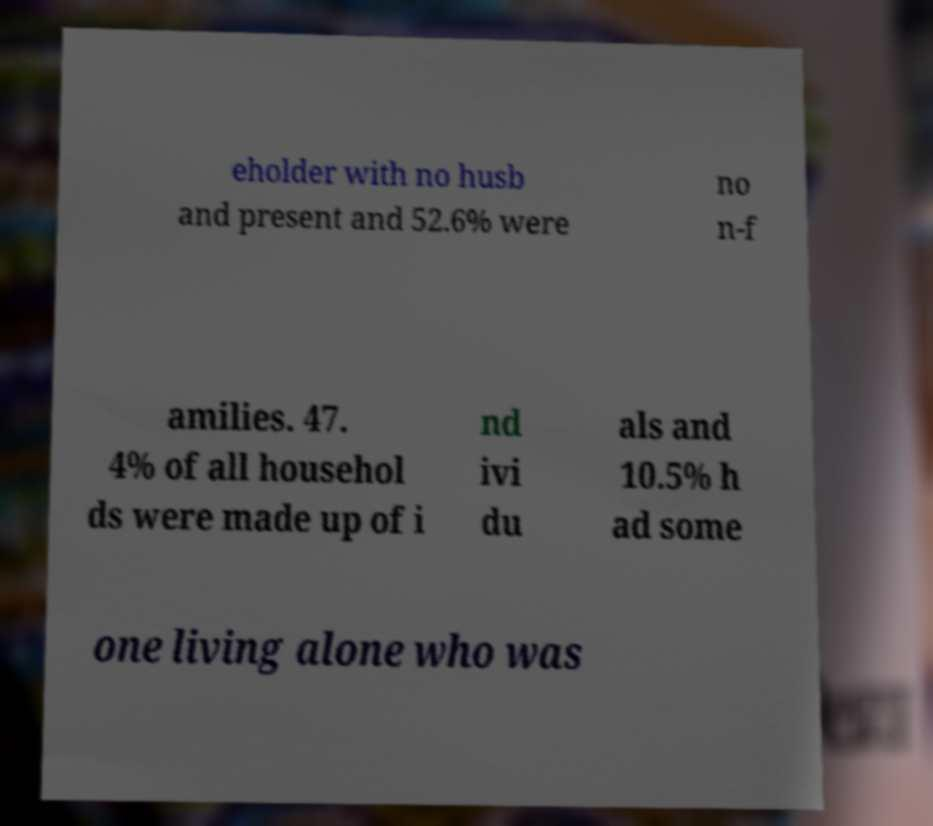For documentation purposes, I need the text within this image transcribed. Could you provide that? eholder with no husb and present and 52.6% were no n-f amilies. 47. 4% of all househol ds were made up of i nd ivi du als and 10.5% h ad some one living alone who was 